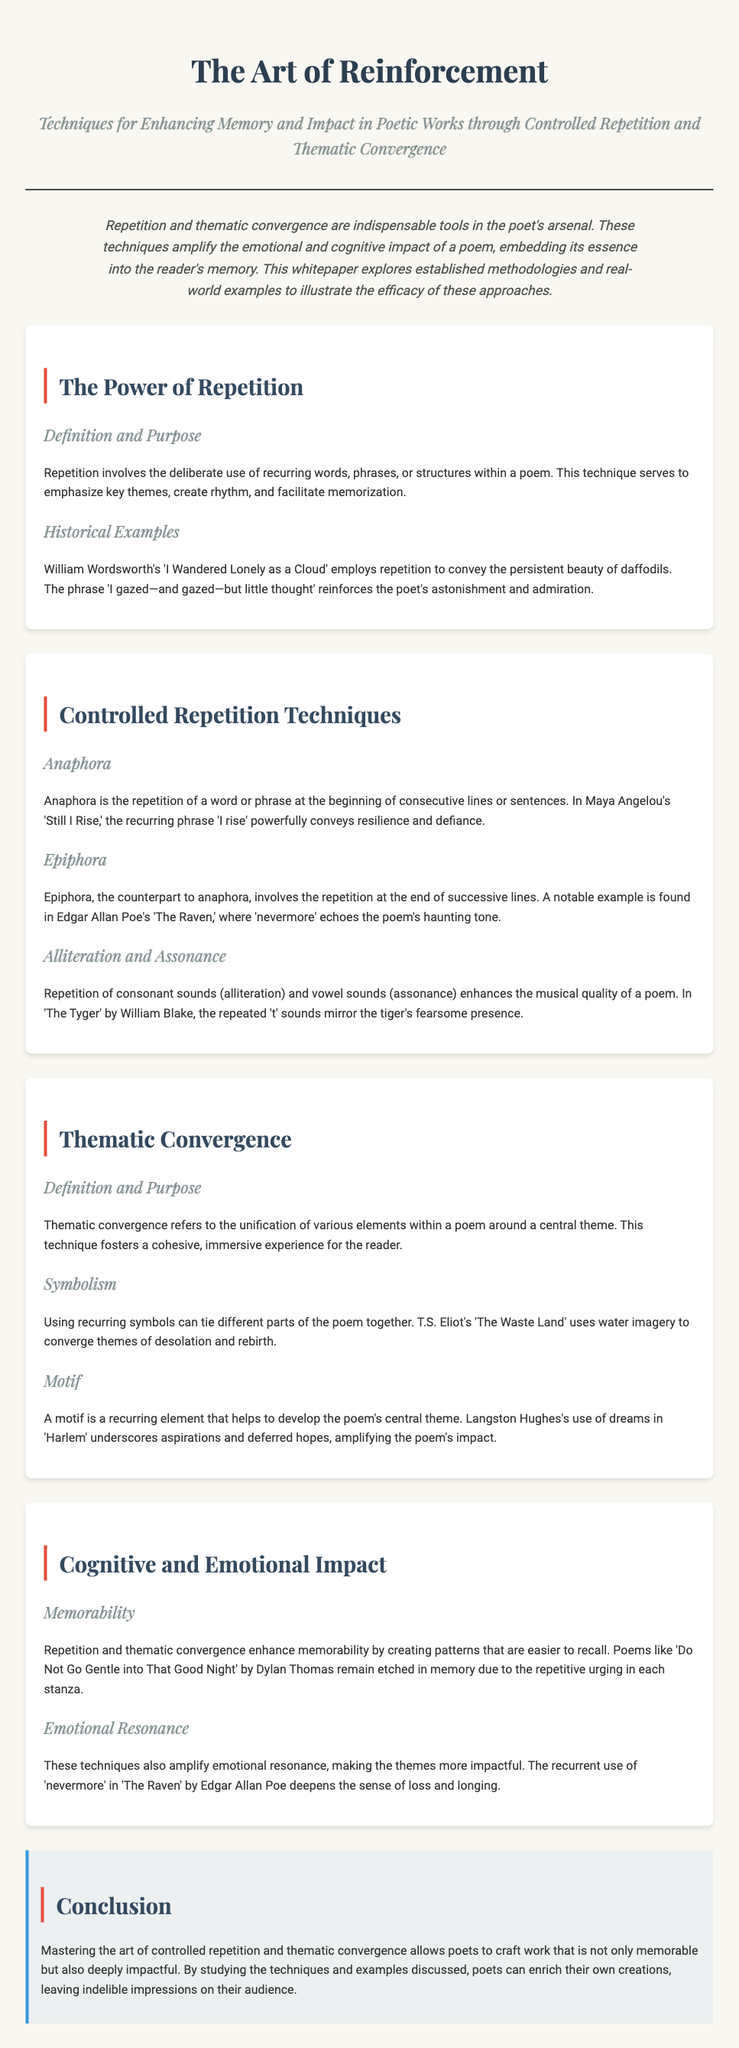What is the title of the whitepaper? The title of the whitepaper is presented at the top of the document.
Answer: The Art of Reinforcement Who authored the phrase 'I rise'? The phrase 'I rise' is from a poem by Maya Angelou, mentioned in the section on anaphora.
Answer: Maya Angelou What literary technique involves the repetition at the beginning of consecutive lines? The document defines this specific repetition technique in the section on controlled repetition.
Answer: Anaphora Which poet uses 'nevermore' in their work? The whitepaper references this word in relation to Edgar Allan Poe's poem in the epiphora section.
Answer: Edgar Allan Poe What is the emotional impact of repetition highlighted in the document? The section on cognitive and emotional impact discusses this effect.
Answer: Emotional resonance How does T.S. Eliot’s 'The Waste Land' utilize imagery? The document explains the use of water imagery to convey themes in Eliot's poem in the thematic convergence section.
Answer: Water imagery What aspect of poetry does the conclusion emphasize as vital for creating impact? The conclusion summarizes key elements discussed throughout the paper that contribute to poetry's effectiveness.
Answer: Controlled repetition What kind of symbolism is used to unify elements within a poem? The section on thematic convergence specifically addresses this unifying technique.
Answer: Recurring symbols Which poem by Dylan Thomas is known for its memorable repetition? The document mentions this poem as an example in the memorability section.
Answer: Do Not Go Gentle into That Good Night 